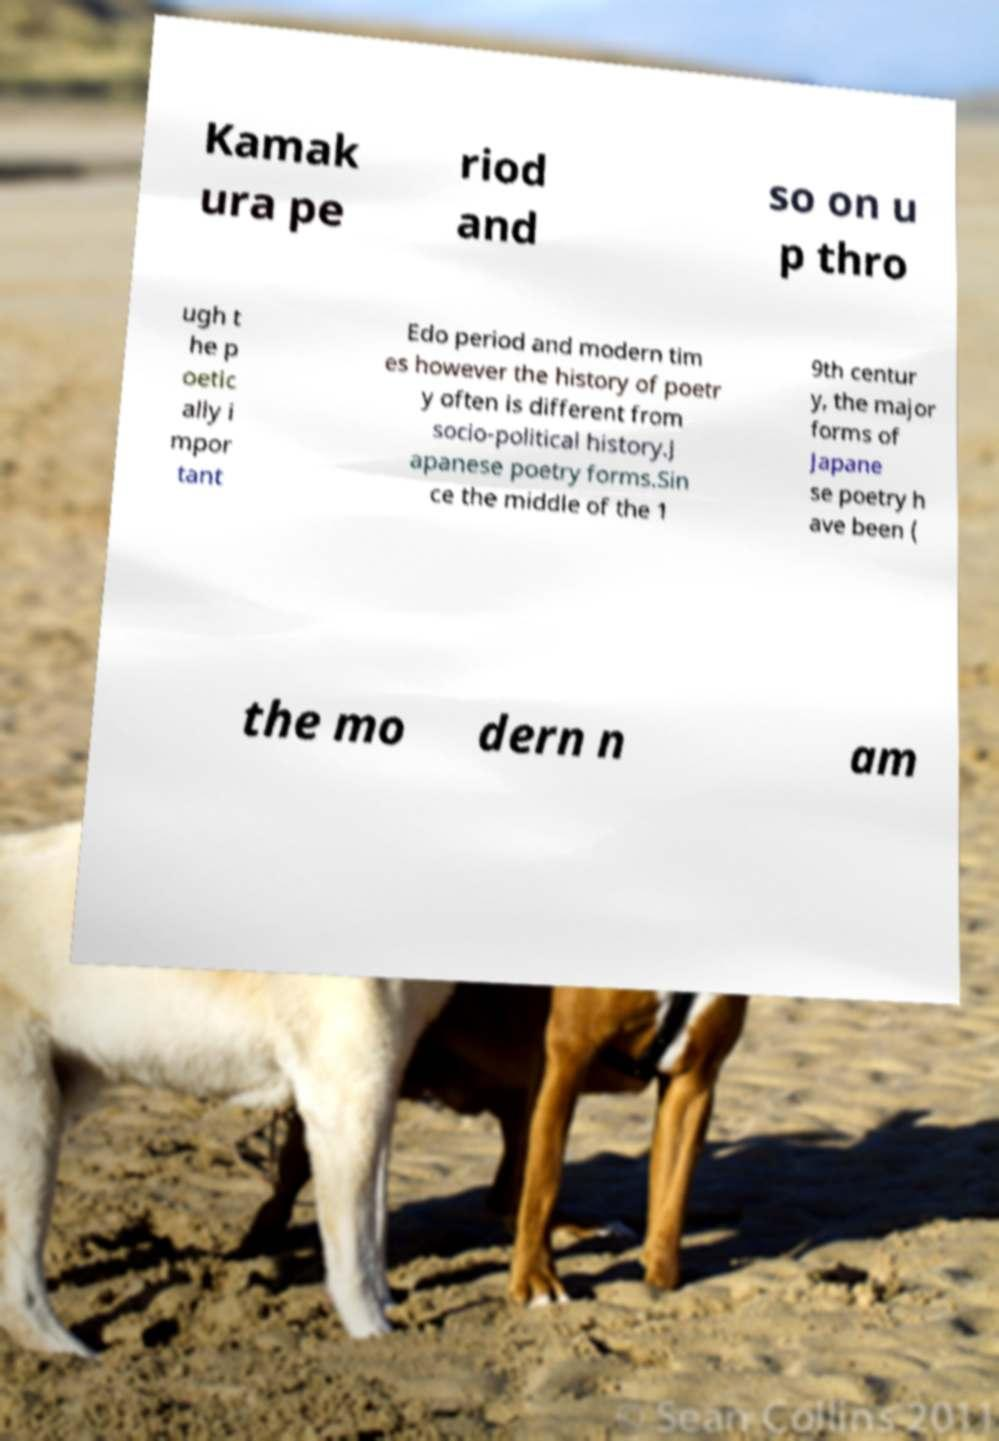Please read and relay the text visible in this image. What does it say? Kamak ura pe riod and so on u p thro ugh t he p oetic ally i mpor tant Edo period and modern tim es however the history of poetr y often is different from socio-political history.J apanese poetry forms.Sin ce the middle of the 1 9th centur y, the major forms of Japane se poetry h ave been ( the mo dern n am 